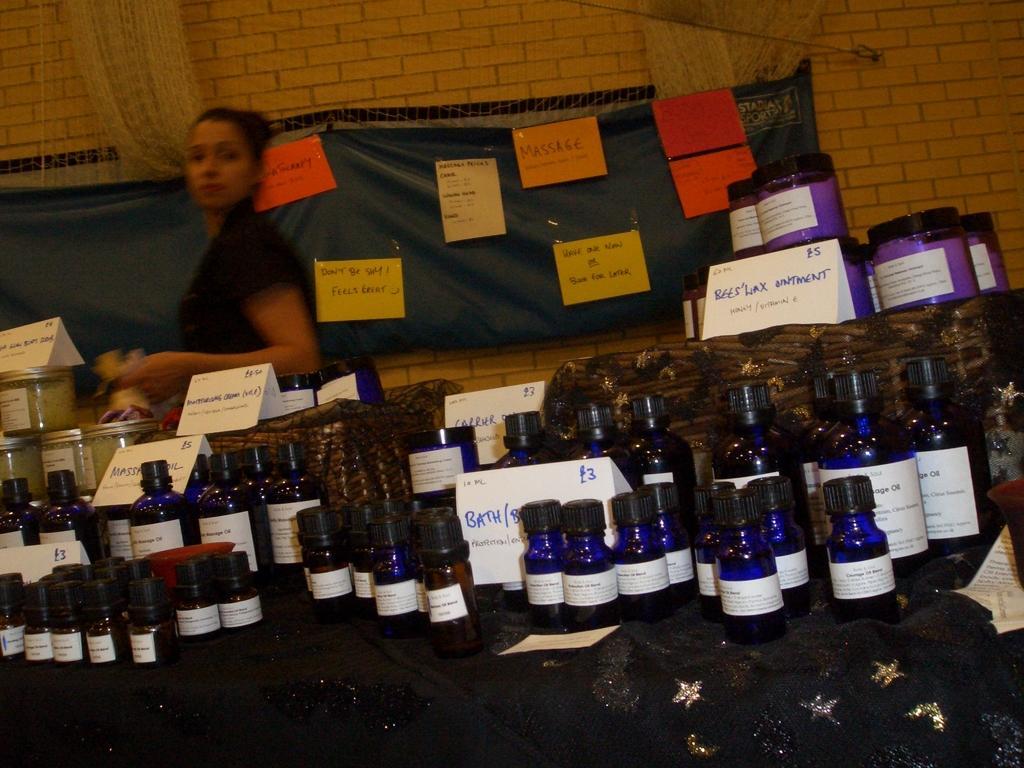In one or two sentences, can you explain what this image depicts? in the picture there are many bottles present on the table with the label ,there is a woman standing over here, in the wall we can see many posts with the message. 